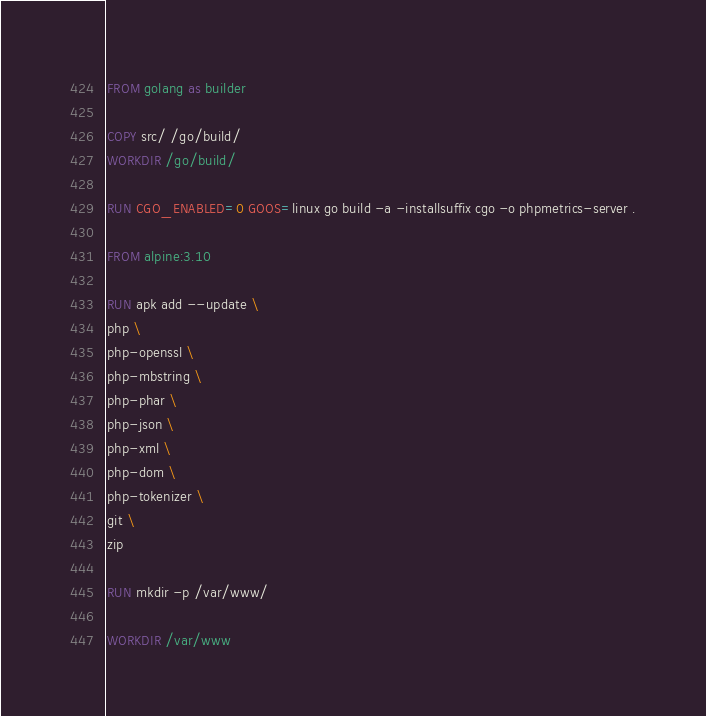Convert code to text. <code><loc_0><loc_0><loc_500><loc_500><_Dockerfile_>FROM golang as builder

COPY src/ /go/build/
WORKDIR /go/build/

RUN CGO_ENABLED=0 GOOS=linux go build -a -installsuffix cgo -o phpmetrics-server .

FROM alpine:3.10

RUN apk add --update \
php \
php-openssl \
php-mbstring \
php-phar \
php-json \
php-xml \
php-dom \
php-tokenizer \
git \
zip

RUN mkdir -p /var/www/

WORKDIR /var/www
</code> 